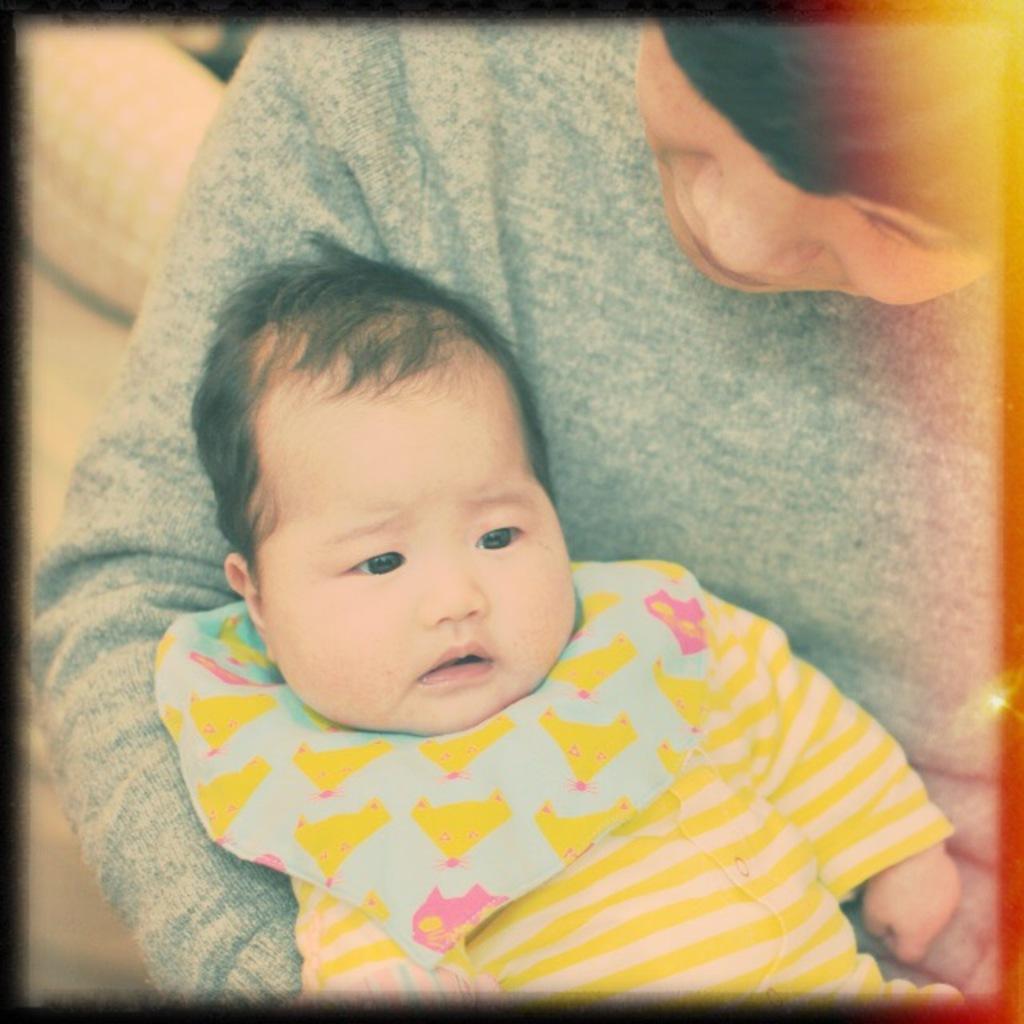Describe this image in one or two sentences. In the picture I can see a person wearing grey color T-shirt is carrying a child who is wearing yellow color dress. 